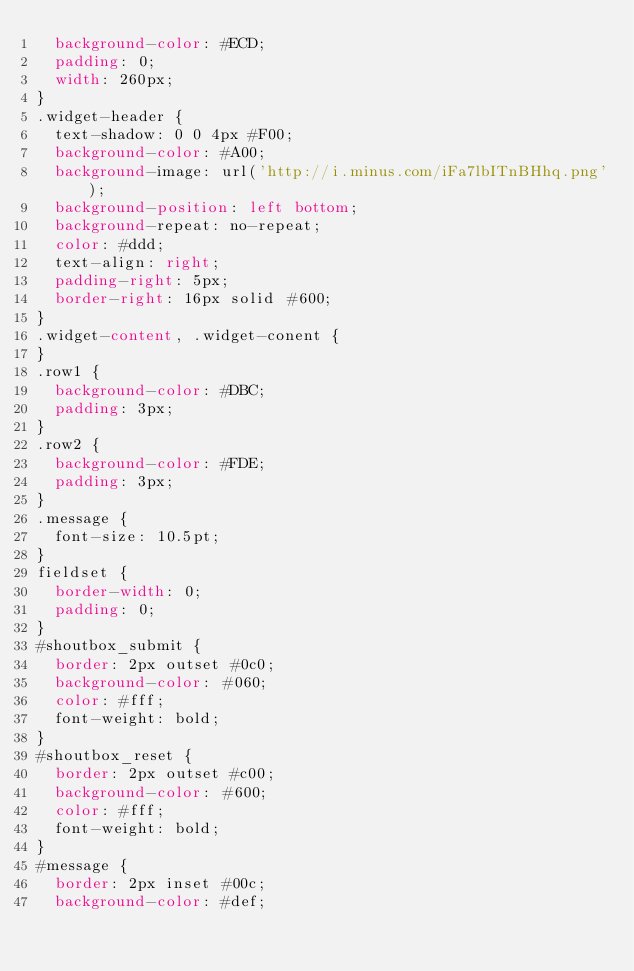Convert code to text. <code><loc_0><loc_0><loc_500><loc_500><_CSS_>  background-color: #ECD;
  padding: 0;
  width: 260px;
}
.widget-header {
  text-shadow: 0 0 4px #F00;
  background-color: #A00;
  background-image: url('http://i.minus.com/iFa7lbITnBHhq.png');
  background-position: left bottom;
  background-repeat: no-repeat;
  color: #ddd;
  text-align: right;
  padding-right: 5px;
  border-right: 16px solid #600;
}
.widget-content, .widget-conent {
}
.row1 {
  background-color: #DBC;
  padding: 3px;
}
.row2 {
  background-color: #FDE;
  padding: 3px;
}
.message {
  font-size: 10.5pt; 
}
fieldset {
  border-width: 0;
  padding: 0;
}
#shoutbox_submit {
  border: 2px outset #0c0;
  background-color: #060;
  color: #fff;
  font-weight: bold;
}
#shoutbox_reset {
  border: 2px outset #c00;
  background-color: #600;
  color: #fff;
  font-weight: bold;
}
#message {
  border: 2px inset #00c;
  background-color: #def;</code> 